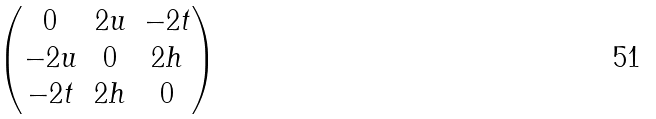Convert formula to latex. <formula><loc_0><loc_0><loc_500><loc_500>\begin{pmatrix} 0 & 2 u & - 2 t \\ - 2 u & 0 & 2 h \\ - 2 t & 2 h & 0 \end{pmatrix}</formula> 